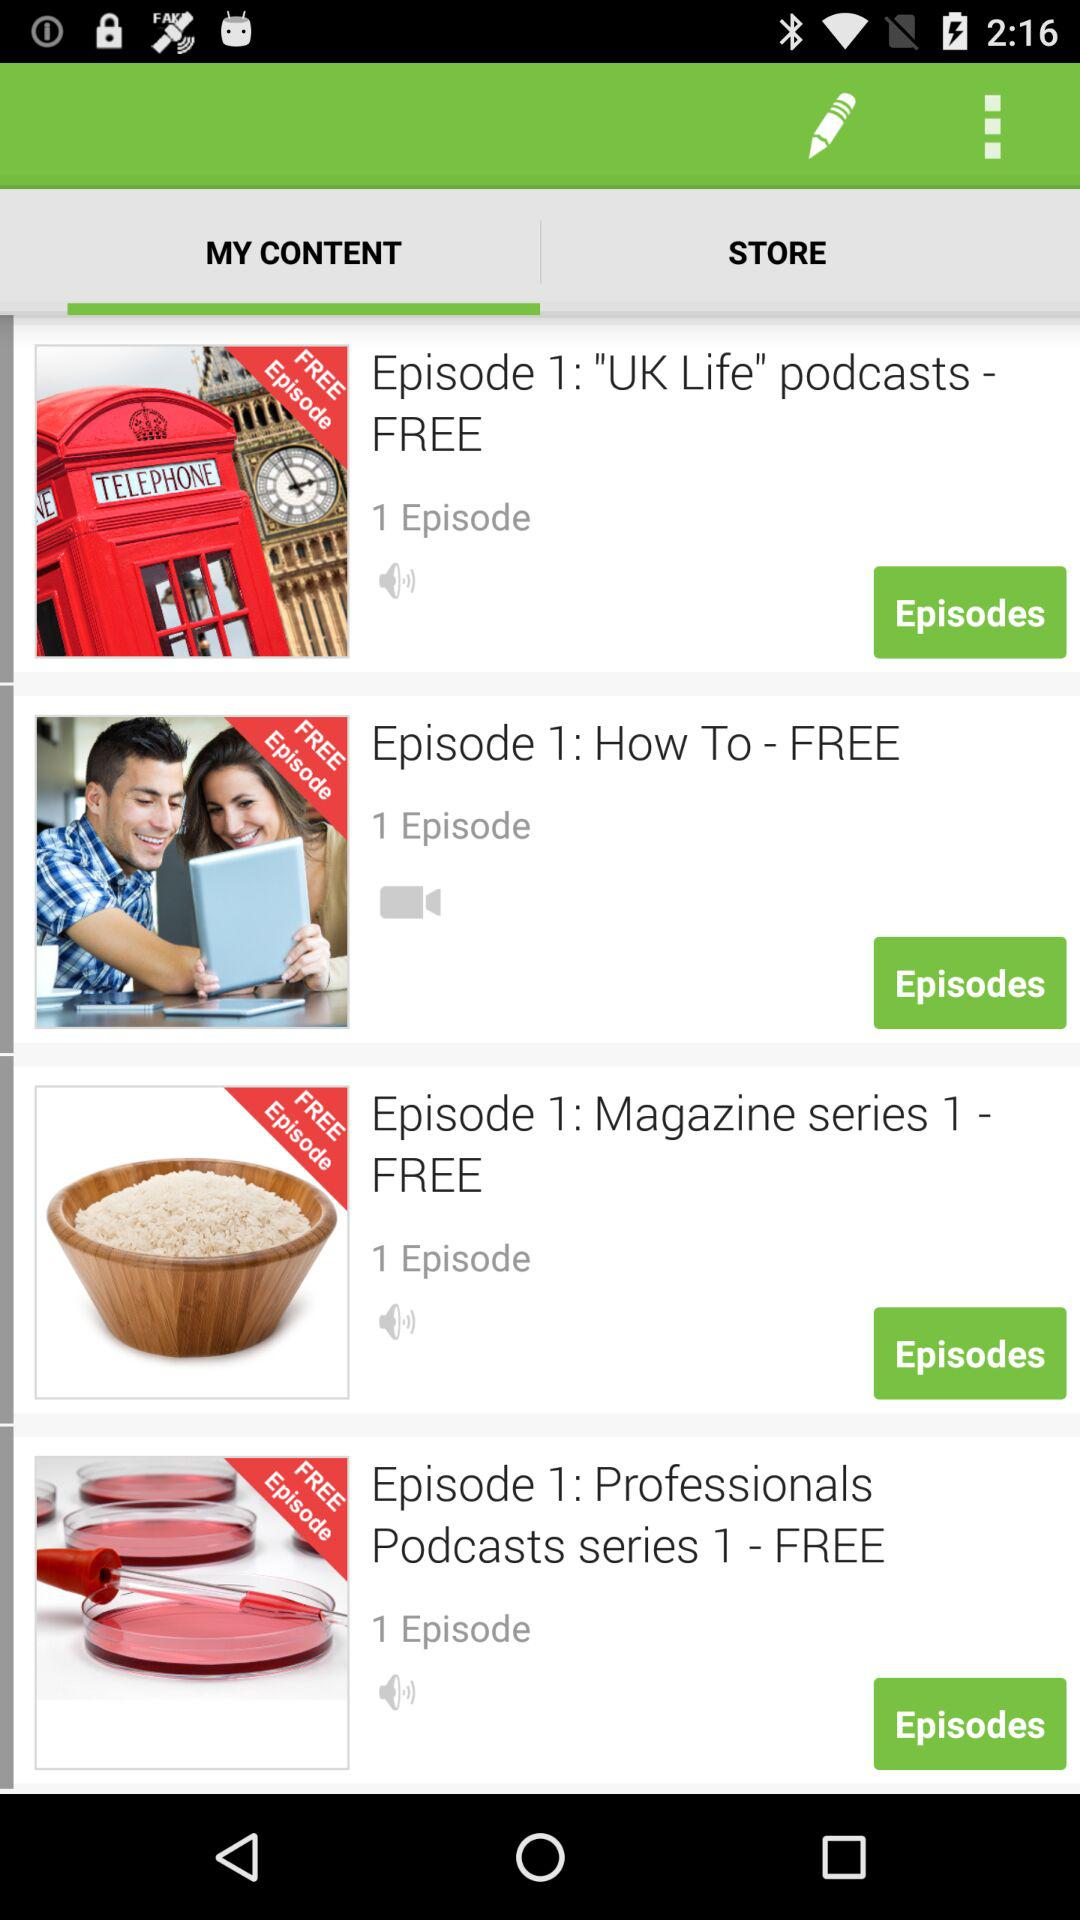How many episodes are free?
Answer the question using a single word or phrase. 4 